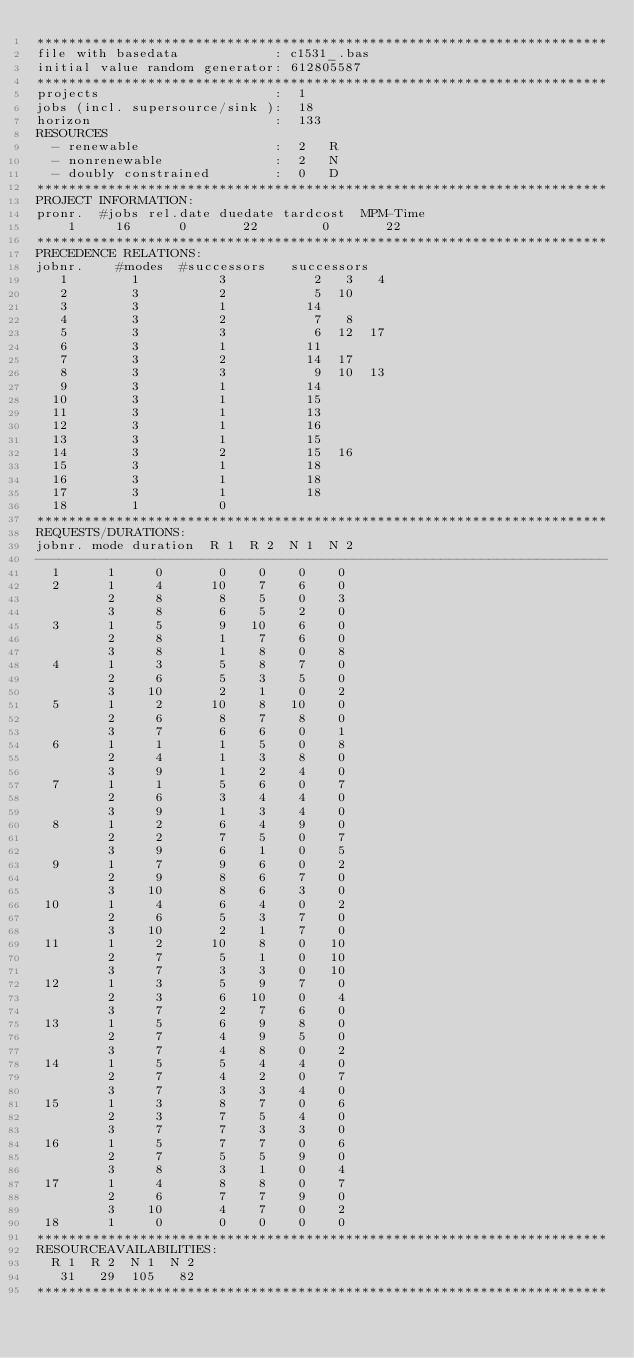<code> <loc_0><loc_0><loc_500><loc_500><_ObjectiveC_>************************************************************************
file with basedata            : c1531_.bas
initial value random generator: 612805587
************************************************************************
projects                      :  1
jobs (incl. supersource/sink ):  18
horizon                       :  133
RESOURCES
  - renewable                 :  2   R
  - nonrenewable              :  2   N
  - doubly constrained        :  0   D
************************************************************************
PROJECT INFORMATION:
pronr.  #jobs rel.date duedate tardcost  MPM-Time
    1     16      0       22        0       22
************************************************************************
PRECEDENCE RELATIONS:
jobnr.    #modes  #successors   successors
   1        1          3           2   3   4
   2        3          2           5  10
   3        3          1          14
   4        3          2           7   8
   5        3          3           6  12  17
   6        3          1          11
   7        3          2          14  17
   8        3          3           9  10  13
   9        3          1          14
  10        3          1          15
  11        3          1          13
  12        3          1          16
  13        3          1          15
  14        3          2          15  16
  15        3          1          18
  16        3          1          18
  17        3          1          18
  18        1          0        
************************************************************************
REQUESTS/DURATIONS:
jobnr. mode duration  R 1  R 2  N 1  N 2
------------------------------------------------------------------------
  1      1     0       0    0    0    0
  2      1     4      10    7    6    0
         2     8       8    5    0    3
         3     8       6    5    2    0
  3      1     5       9   10    6    0
         2     8       1    7    6    0
         3     8       1    8    0    8
  4      1     3       5    8    7    0
         2     6       5    3    5    0
         3    10       2    1    0    2
  5      1     2      10    8   10    0
         2     6       8    7    8    0
         3     7       6    6    0    1
  6      1     1       1    5    0    8
         2     4       1    3    8    0
         3     9       1    2    4    0
  7      1     1       5    6    0    7
         2     6       3    4    4    0
         3     9       1    3    4    0
  8      1     2       6    4    9    0
         2     2       7    5    0    7
         3     9       6    1    0    5
  9      1     7       9    6    0    2
         2     9       8    6    7    0
         3    10       8    6    3    0
 10      1     4       6    4    0    2
         2     6       5    3    7    0
         3    10       2    1    7    0
 11      1     2      10    8    0   10
         2     7       5    1    0   10
         3     7       3    3    0   10
 12      1     3       5    9    7    0
         2     3       6   10    0    4
         3     7       2    7    6    0
 13      1     5       6    9    8    0
         2     7       4    9    5    0
         3     7       4    8    0    2
 14      1     5       5    4    4    0
         2     7       4    2    0    7
         3     7       3    3    4    0
 15      1     3       8    7    0    6
         2     3       7    5    4    0
         3     7       7    3    3    0
 16      1     5       7    7    0    6
         2     7       5    5    9    0
         3     8       3    1    0    4
 17      1     4       8    8    0    7
         2     6       7    7    9    0
         3    10       4    7    0    2
 18      1     0       0    0    0    0
************************************************************************
RESOURCEAVAILABILITIES:
  R 1  R 2  N 1  N 2
   31   29  105   82
************************************************************************
</code> 